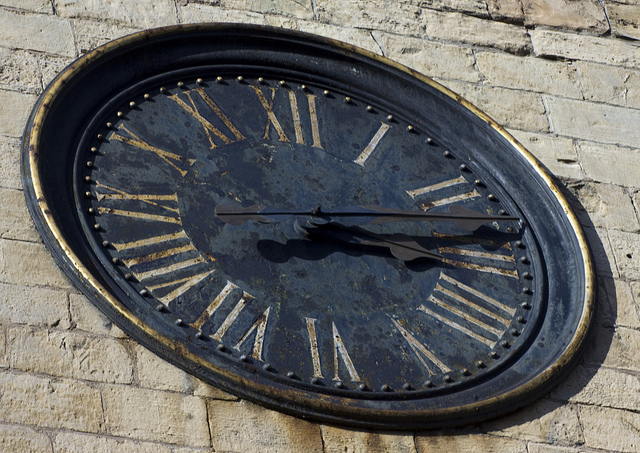What time is it on the clock, and does the time seem accurate? Based on the position of the hands, the clock shows a time around 10:08. However, without additional context it's not possible to confirm if the clock is working and if the depicted time is accurate. 